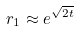Convert formula to latex. <formula><loc_0><loc_0><loc_500><loc_500>r _ { 1 } \approx e ^ { \sqrt { 2 t } }</formula> 